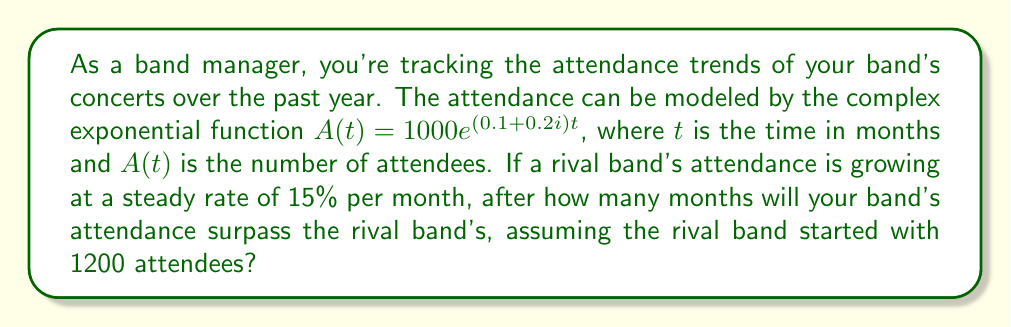What is the answer to this math problem? Let's approach this step-by-step:

1) Your band's attendance is modeled by $A(t) = 1000e^{(0.1 + 0.2i)t}$

2) To find the actual attendance, we need the magnitude of this complex function:
   $|A(t)| = 1000|e^{(0.1 + 0.2i)t}| = 1000e^{0.1t}$

3) The rival band's attendance can be modeled as $R(t) = 1200(1.15)^t$

4) We need to find $t$ where $|A(t)| > R(t)$:

   $1000e^{0.1t} > 1200(1.15)^t$

5) Taking natural log of both sides:

   $\ln(1000) + 0.1t > \ln(1200) + t\ln(1.15)$

6) Simplify:

   $6.908 + 0.1t > 7.090 + 0.140t$

7) Solve for $t$:

   $0.1t - 0.140t > 7.090 - 6.908$
   $-0.04t > 0.182$
   $t > -4.55$

8) Since time can't be negative, and we need the first month where attendance is higher, we round up to the nearest whole number.
Answer: The band's attendance will surpass the rival band's after 5 months. 